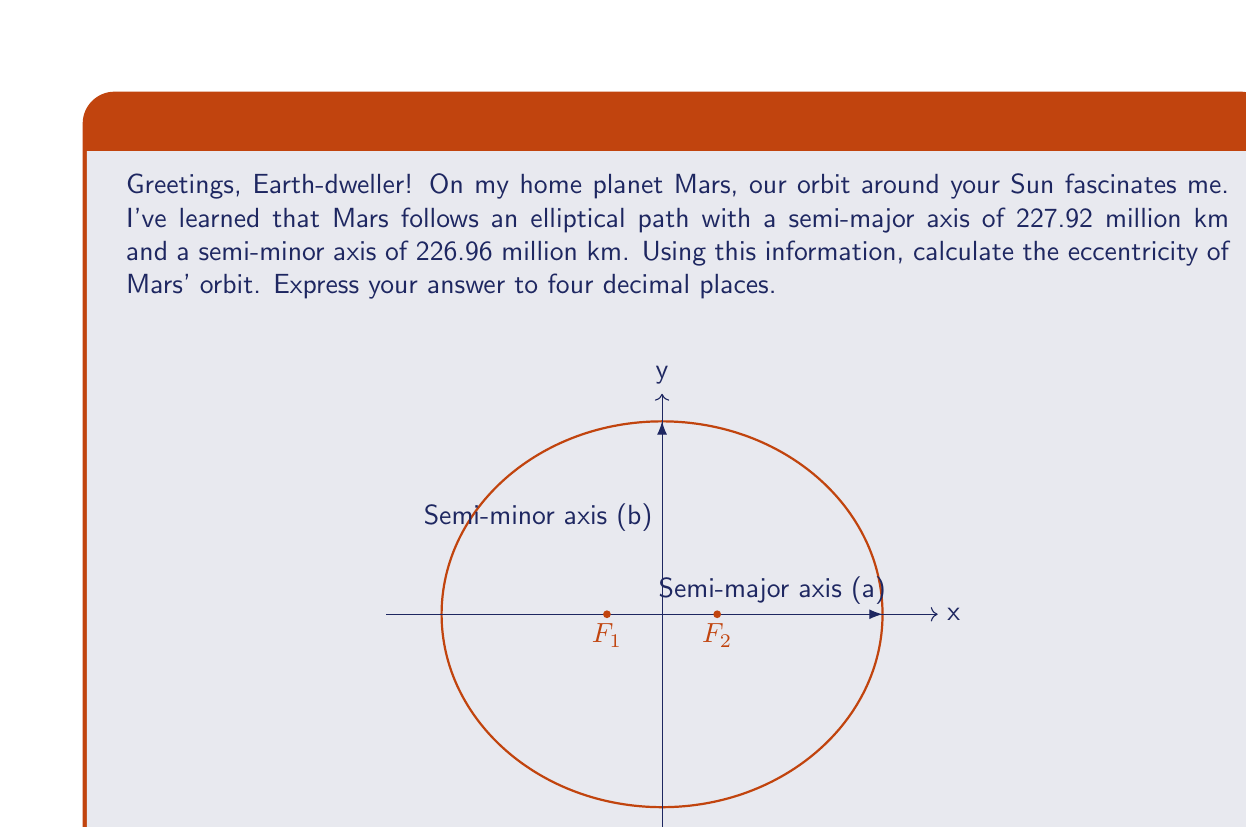What is the answer to this math problem? Let's approach this step-by-step:

1) The eccentricity (e) of an ellipse is defined by the formula:

   $$e = \sqrt{1 - \frac{b^2}{a^2}}$$

   where $a$ is the semi-major axis and $b$ is the semi-minor axis.

2) We are given:
   $a = 227.92$ million km
   $b = 226.96$ million km

3) Let's substitute these values into the formula:

   $$e = \sqrt{1 - \frac{(226.96)^2}{(227.92)^2}}$$

4) Now, let's calculate:

   $$e = \sqrt{1 - \frac{51510.4416}{51947.7264}}$$

5) Simplify:

   $$e = \sqrt{1 - 0.9916009}$$

6) Subtract:

   $$e = \sqrt{0.0083991}$$

7) Take the square root:

   $$e \approx 0.0916466$$

8) Rounding to four decimal places:

   $$e \approx 0.0916$$
Answer: 0.0916 